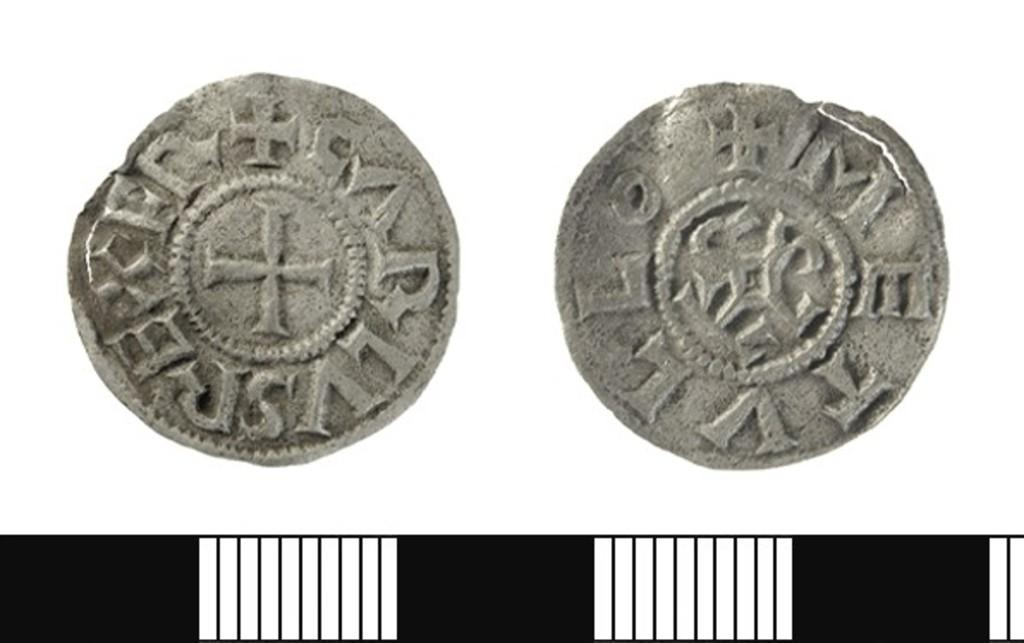What can be observed about the image's appearance? The image is edited. What objects are present in the image? There are two coins in the image. What is the color of the background in the image? There is a white background in the image. What type of list can be seen in the image? There is no list present in the image; it only contains two coins on a white background. How many cars are visible in the image? There are no cars visible in the image; it only contains two coins on a white background. 